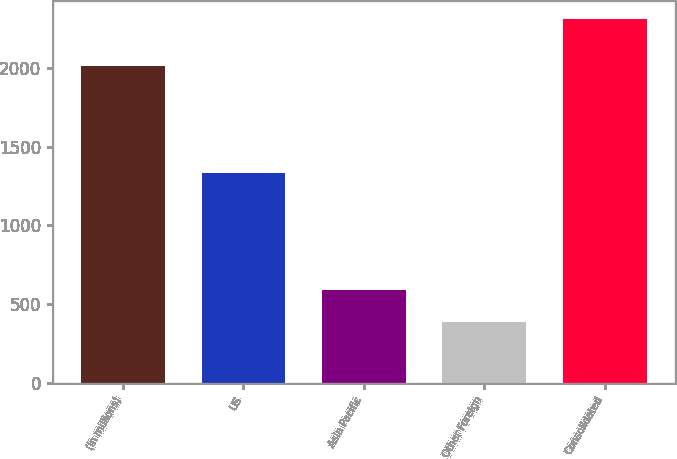<chart> <loc_0><loc_0><loc_500><loc_500><bar_chart><fcel>(in millions)<fcel>US<fcel>Asia Pacific<fcel>Other Foreign<fcel>Consolidated<nl><fcel>2011<fcel>1330<fcel>591<fcel>386<fcel>2307<nl></chart> 